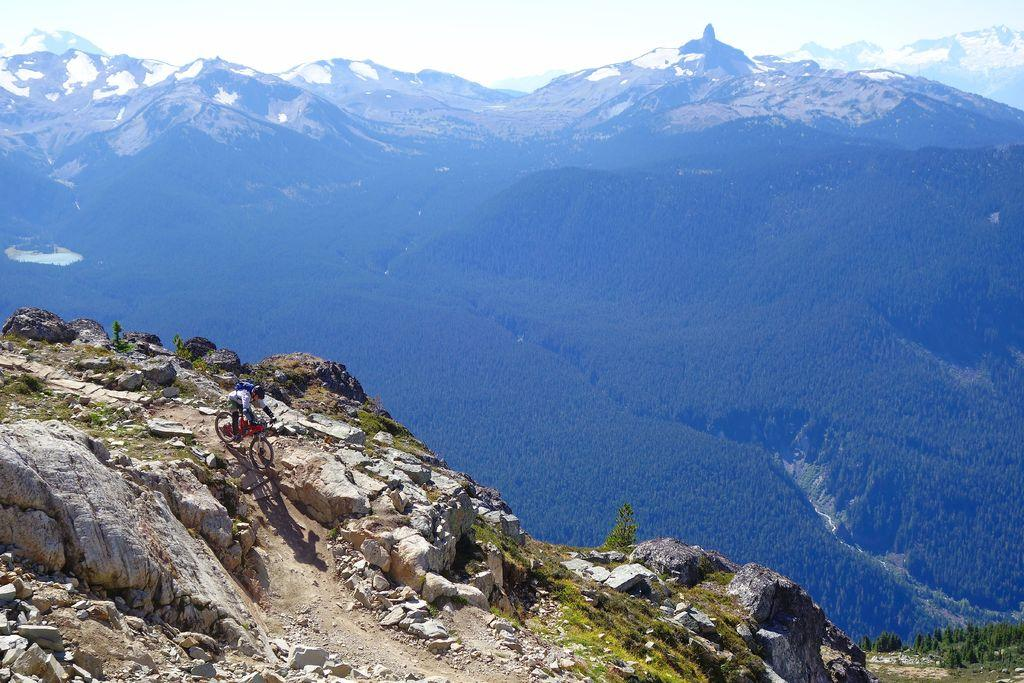What is located at the front of the image? There are stones in the front of the image. What is the person in the image doing? There is a person riding a bicycle in the image. What can be seen in the background of the image? There are trees and mountains in the background of the image. What type of vegetation is on the right side of the image? There is grass on the ground on the right side of the image. Can you see any air vents in the cellar through the window in the image? There is no cellar or window present in the image. What type of window can be seen in the image? There is no window present in the image. 